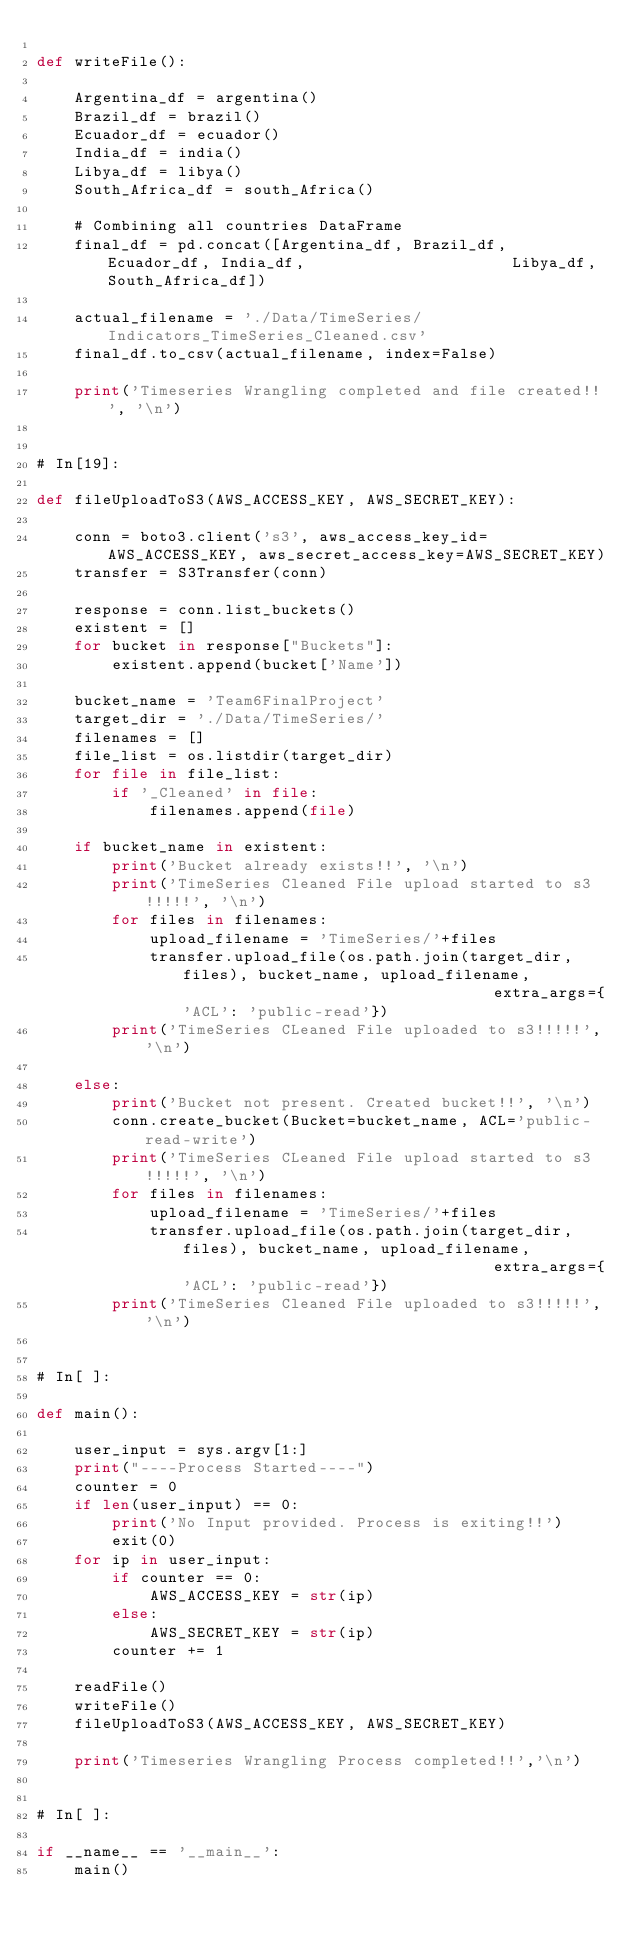<code> <loc_0><loc_0><loc_500><loc_500><_Python_>
def writeFile():

    Argentina_df = argentina()
    Brazil_df = brazil()
    Ecuador_df = ecuador()
    India_df = india()
    Libya_df = libya()
    South_Africa_df = south_Africa()
    
    # Combining all countries DataFrame
    final_df = pd.concat([Argentina_df, Brazil_df, Ecuador_df, India_df,                      Libya_df, South_Africa_df])

    actual_filename = './Data/TimeSeries/Indicators_TimeSeries_Cleaned.csv'
    final_df.to_csv(actual_filename, index=False)
    
    print('Timeseries Wrangling completed and file created!!', '\n')


# In[19]:

def fileUploadToS3(AWS_ACCESS_KEY, AWS_SECRET_KEY):
    
    conn = boto3.client('s3', aws_access_key_id=AWS_ACCESS_KEY, aws_secret_access_key=AWS_SECRET_KEY)
    transfer = S3Transfer(conn)

    response = conn.list_buckets()    
    existent = []
    for bucket in response["Buckets"]:
        existent.append(bucket['Name'])

    bucket_name = 'Team6FinalProject'
    target_dir = './Data/TimeSeries/'
    filenames = []
    file_list = os.listdir(target_dir)
    for file in file_list:
        if '_Cleaned' in file:
            filenames.append(file)

    if bucket_name in existent:
        print('Bucket already exists!!', '\n')
        print('TimeSeries Cleaned File upload started to s3!!!!!', '\n')
        for files in filenames:
            upload_filename = 'TimeSeries/'+files
            transfer.upload_file(os.path.join(target_dir, files), bucket_name, upload_filename,                                  extra_args={'ACL': 'public-read'})
        print('TimeSeries CLeaned File uploaded to s3!!!!!','\n')
            
    else:
        print('Bucket not present. Created bucket!!', '\n')
        conn.create_bucket(Bucket=bucket_name, ACL='public-read-write')
        print('TimeSeries CLeaned File upload started to s3!!!!!', '\n')
        for files in filenames:
            upload_filename = 'TimeSeries/'+files
            transfer.upload_file(os.path.join(target_dir, files), bucket_name, upload_filename,                                  extra_args={'ACL': 'public-read'})
        print('TimeSeries Cleaned File uploaded to s3!!!!!','\n')


# In[ ]:

def main():
    
    user_input = sys.argv[1:]
    print("----Process Started----")
    counter = 0
    if len(user_input) == 0:
        print('No Input provided. Process is exiting!!')
        exit(0)
    for ip in user_input:
        if counter == 0:
            AWS_ACCESS_KEY = str(ip)
        else:
            AWS_SECRET_KEY = str(ip)
        counter += 1
    
    readFile()
    writeFile()
    fileUploadToS3(AWS_ACCESS_KEY, AWS_SECRET_KEY)
    
    print('Timeseries Wrangling Process completed!!','\n')


# In[ ]:

if __name__ == '__main__':
    main()

</code> 